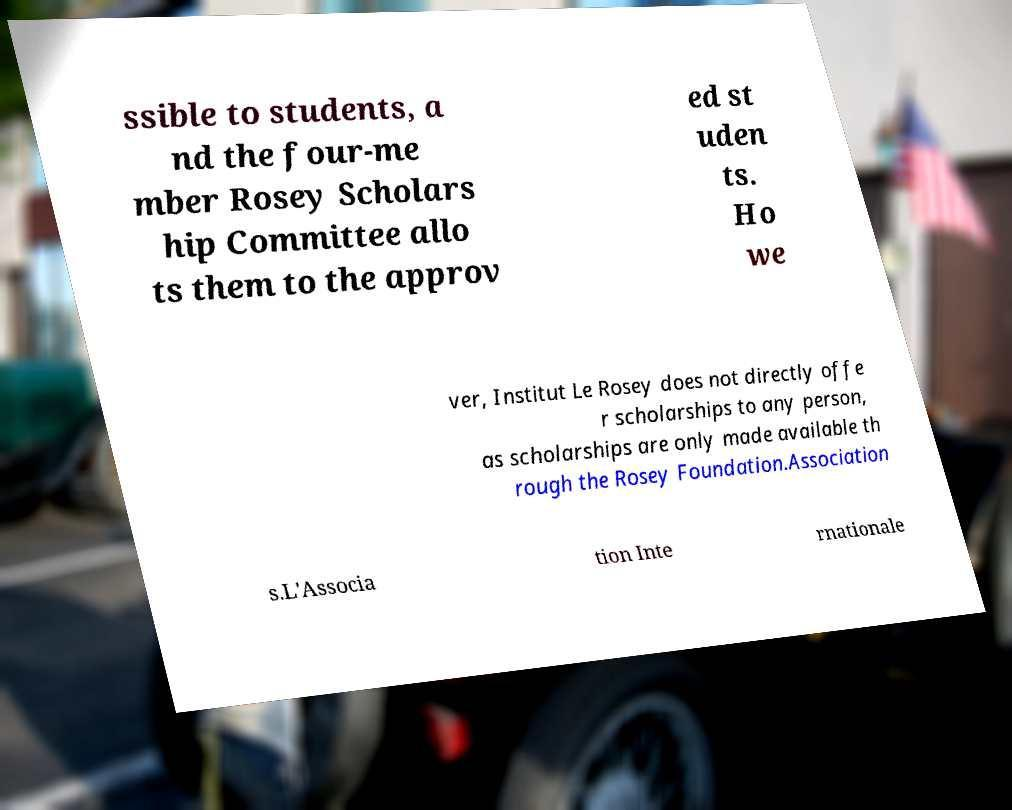Can you read and provide the text displayed in the image?This photo seems to have some interesting text. Can you extract and type it out for me? ssible to students, a nd the four-me mber Rosey Scholars hip Committee allo ts them to the approv ed st uden ts. Ho we ver, Institut Le Rosey does not directly offe r scholarships to any person, as scholarships are only made available th rough the Rosey Foundation.Association s.L'Associa tion Inte rnationale 